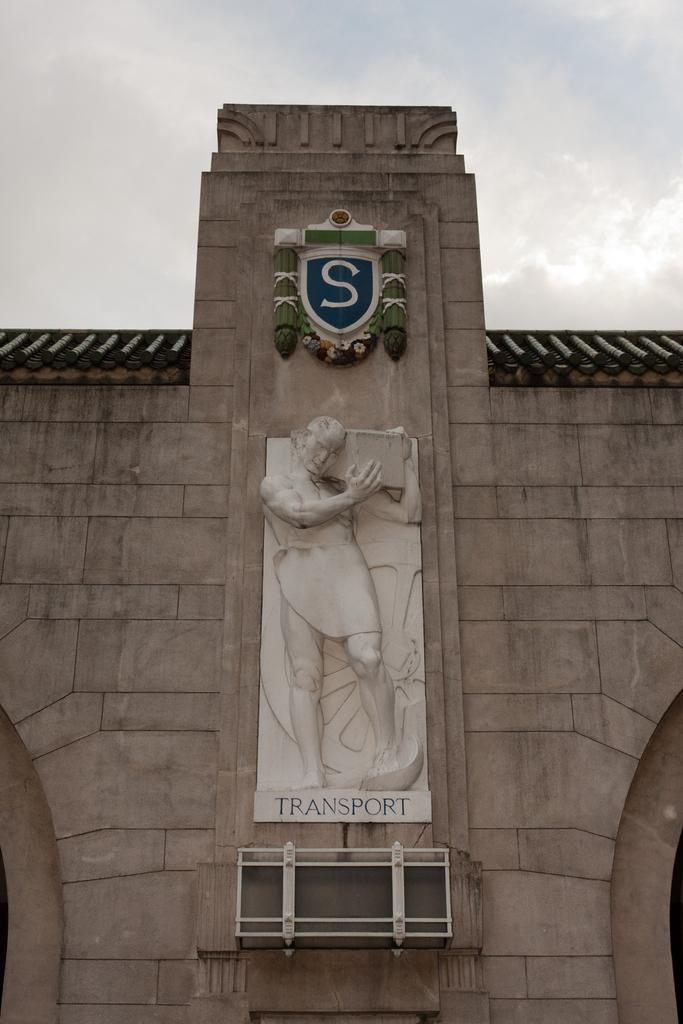<image>
Share a concise interpretation of the image provided. An engraving on a building front above the word "transport". 